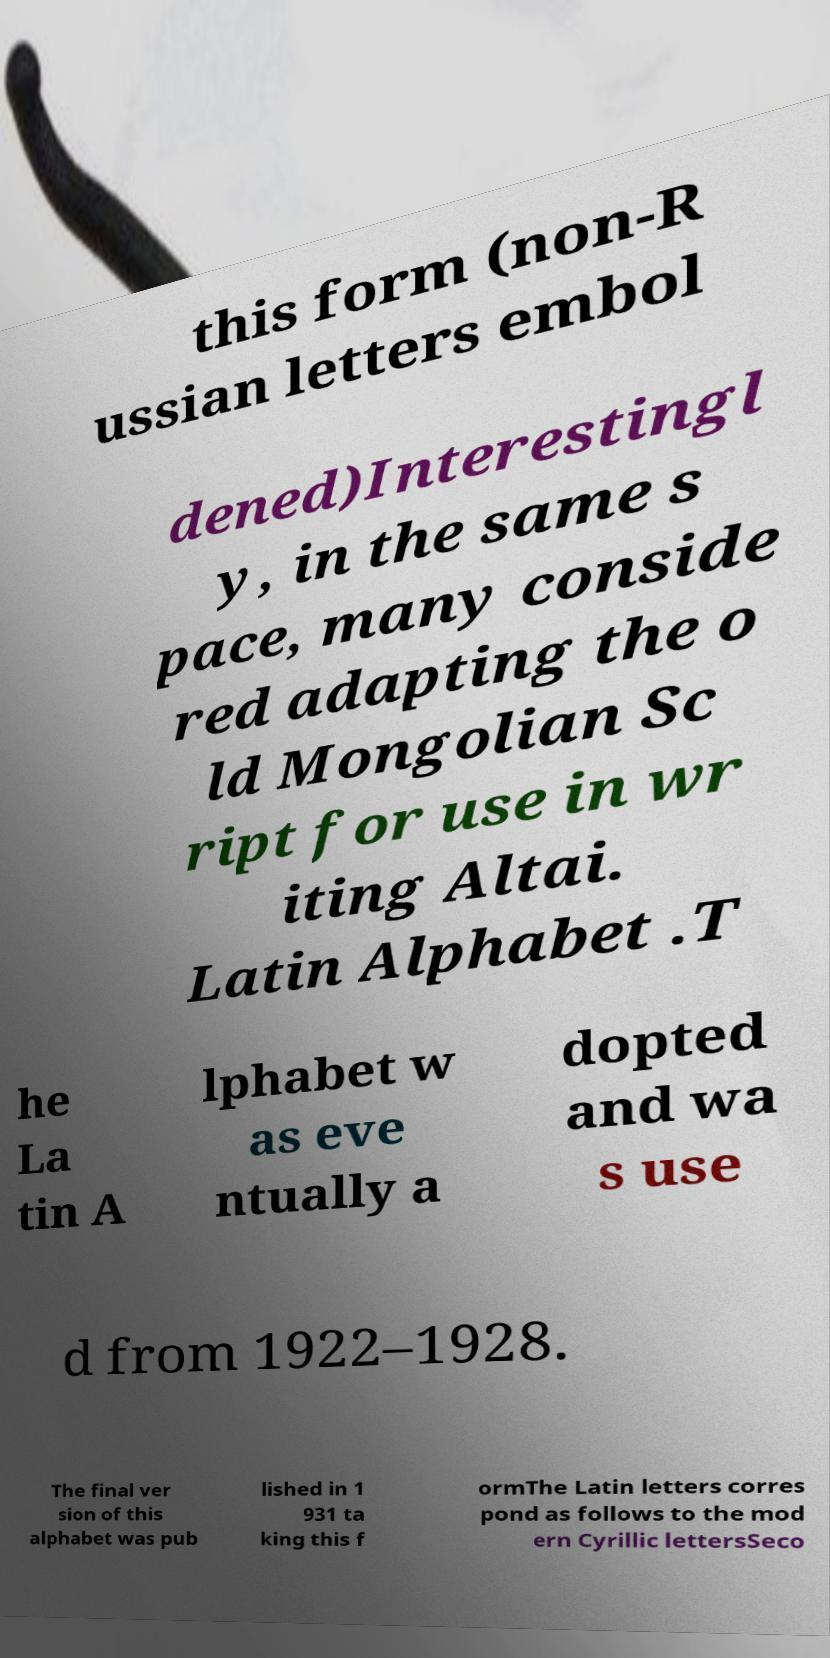For documentation purposes, I need the text within this image transcribed. Could you provide that? this form (non-R ussian letters embol dened)Interestingl y, in the same s pace, many conside red adapting the o ld Mongolian Sc ript for use in wr iting Altai. Latin Alphabet .T he La tin A lphabet w as eve ntually a dopted and wa s use d from 1922–1928. The final ver sion of this alphabet was pub lished in 1 931 ta king this f ormThe Latin letters corres pond as follows to the mod ern Cyrillic lettersSeco 